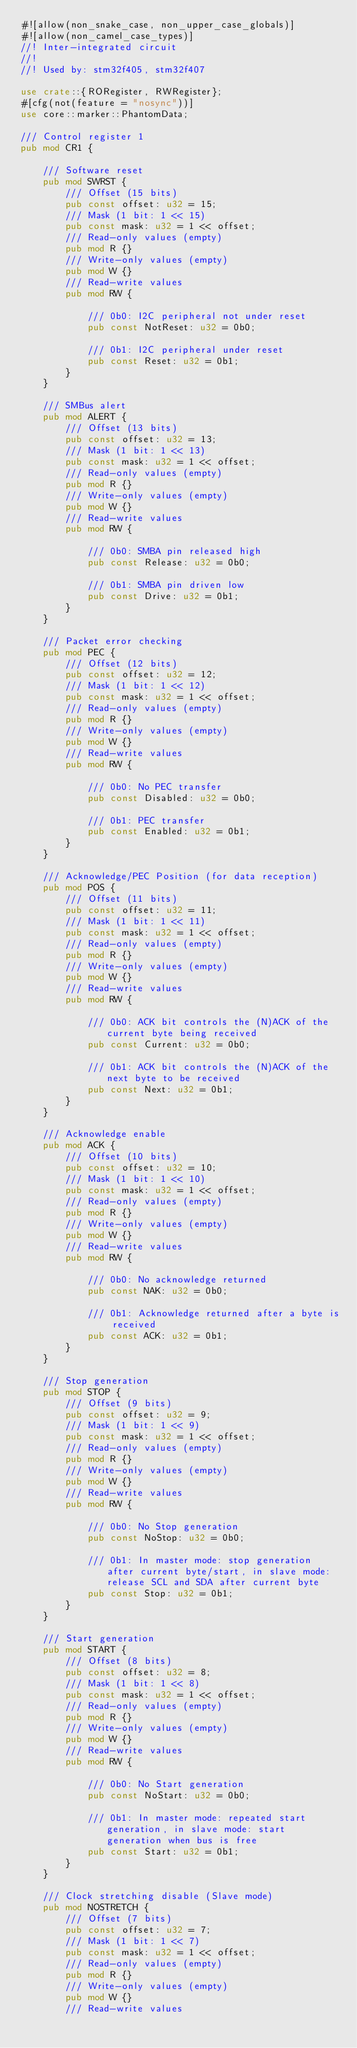<code> <loc_0><loc_0><loc_500><loc_500><_Rust_>#![allow(non_snake_case, non_upper_case_globals)]
#![allow(non_camel_case_types)]
//! Inter-integrated circuit
//!
//! Used by: stm32f405, stm32f407

use crate::{RORegister, RWRegister};
#[cfg(not(feature = "nosync"))]
use core::marker::PhantomData;

/// Control register 1
pub mod CR1 {

    /// Software reset
    pub mod SWRST {
        /// Offset (15 bits)
        pub const offset: u32 = 15;
        /// Mask (1 bit: 1 << 15)
        pub const mask: u32 = 1 << offset;
        /// Read-only values (empty)
        pub mod R {}
        /// Write-only values (empty)
        pub mod W {}
        /// Read-write values
        pub mod RW {

            /// 0b0: I2C peripheral not under reset
            pub const NotReset: u32 = 0b0;

            /// 0b1: I2C peripheral under reset
            pub const Reset: u32 = 0b1;
        }
    }

    /// SMBus alert
    pub mod ALERT {
        /// Offset (13 bits)
        pub const offset: u32 = 13;
        /// Mask (1 bit: 1 << 13)
        pub const mask: u32 = 1 << offset;
        /// Read-only values (empty)
        pub mod R {}
        /// Write-only values (empty)
        pub mod W {}
        /// Read-write values
        pub mod RW {

            /// 0b0: SMBA pin released high
            pub const Release: u32 = 0b0;

            /// 0b1: SMBA pin driven low
            pub const Drive: u32 = 0b1;
        }
    }

    /// Packet error checking
    pub mod PEC {
        /// Offset (12 bits)
        pub const offset: u32 = 12;
        /// Mask (1 bit: 1 << 12)
        pub const mask: u32 = 1 << offset;
        /// Read-only values (empty)
        pub mod R {}
        /// Write-only values (empty)
        pub mod W {}
        /// Read-write values
        pub mod RW {

            /// 0b0: No PEC transfer
            pub const Disabled: u32 = 0b0;

            /// 0b1: PEC transfer
            pub const Enabled: u32 = 0b1;
        }
    }

    /// Acknowledge/PEC Position (for data reception)
    pub mod POS {
        /// Offset (11 bits)
        pub const offset: u32 = 11;
        /// Mask (1 bit: 1 << 11)
        pub const mask: u32 = 1 << offset;
        /// Read-only values (empty)
        pub mod R {}
        /// Write-only values (empty)
        pub mod W {}
        /// Read-write values
        pub mod RW {

            /// 0b0: ACK bit controls the (N)ACK of the current byte being received
            pub const Current: u32 = 0b0;

            /// 0b1: ACK bit controls the (N)ACK of the next byte to be received
            pub const Next: u32 = 0b1;
        }
    }

    /// Acknowledge enable
    pub mod ACK {
        /// Offset (10 bits)
        pub const offset: u32 = 10;
        /// Mask (1 bit: 1 << 10)
        pub const mask: u32 = 1 << offset;
        /// Read-only values (empty)
        pub mod R {}
        /// Write-only values (empty)
        pub mod W {}
        /// Read-write values
        pub mod RW {

            /// 0b0: No acknowledge returned
            pub const NAK: u32 = 0b0;

            /// 0b1: Acknowledge returned after a byte is received
            pub const ACK: u32 = 0b1;
        }
    }

    /// Stop generation
    pub mod STOP {
        /// Offset (9 bits)
        pub const offset: u32 = 9;
        /// Mask (1 bit: 1 << 9)
        pub const mask: u32 = 1 << offset;
        /// Read-only values (empty)
        pub mod R {}
        /// Write-only values (empty)
        pub mod W {}
        /// Read-write values
        pub mod RW {

            /// 0b0: No Stop generation
            pub const NoStop: u32 = 0b0;

            /// 0b1: In master mode: stop generation after current byte/start, in slave mode: release SCL and SDA after current byte
            pub const Stop: u32 = 0b1;
        }
    }

    /// Start generation
    pub mod START {
        /// Offset (8 bits)
        pub const offset: u32 = 8;
        /// Mask (1 bit: 1 << 8)
        pub const mask: u32 = 1 << offset;
        /// Read-only values (empty)
        pub mod R {}
        /// Write-only values (empty)
        pub mod W {}
        /// Read-write values
        pub mod RW {

            /// 0b0: No Start generation
            pub const NoStart: u32 = 0b0;

            /// 0b1: In master mode: repeated start generation, in slave mode: start generation when bus is free
            pub const Start: u32 = 0b1;
        }
    }

    /// Clock stretching disable (Slave mode)
    pub mod NOSTRETCH {
        /// Offset (7 bits)
        pub const offset: u32 = 7;
        /// Mask (1 bit: 1 << 7)
        pub const mask: u32 = 1 << offset;
        /// Read-only values (empty)
        pub mod R {}
        /// Write-only values (empty)
        pub mod W {}
        /// Read-write values</code> 